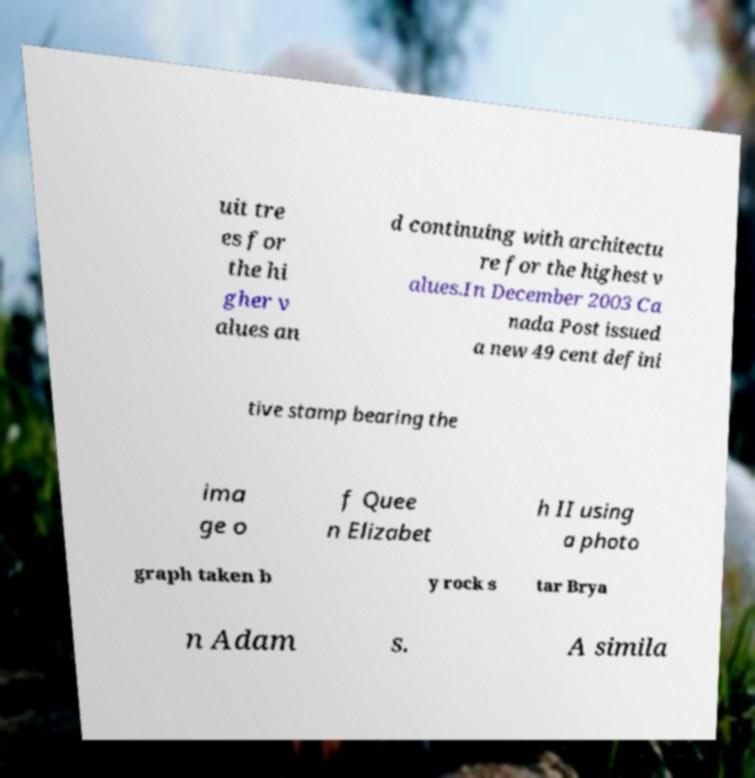Can you accurately transcribe the text from the provided image for me? uit tre es for the hi gher v alues an d continuing with architectu re for the highest v alues.In December 2003 Ca nada Post issued a new 49 cent defini tive stamp bearing the ima ge o f Quee n Elizabet h II using a photo graph taken b y rock s tar Brya n Adam s. A simila 